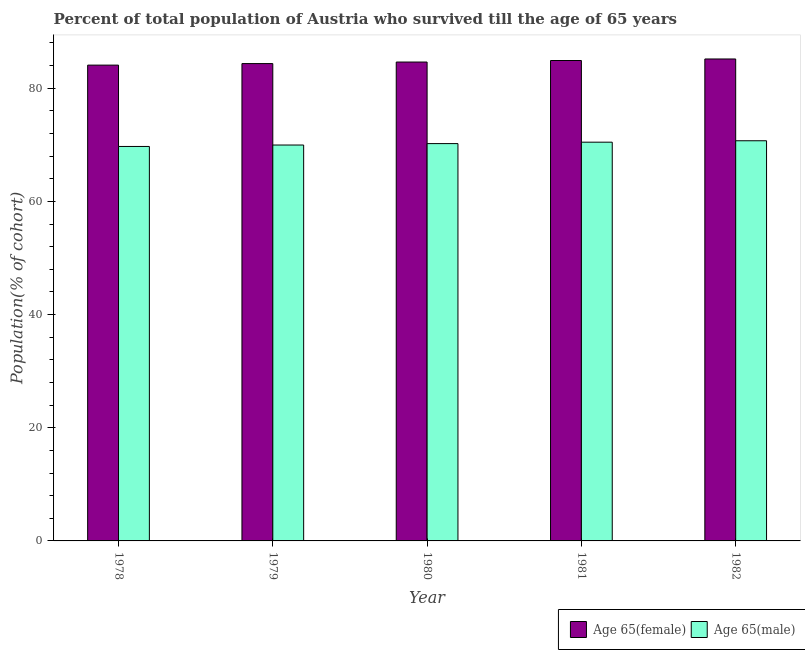How many different coloured bars are there?
Ensure brevity in your answer.  2. How many groups of bars are there?
Your answer should be very brief. 5. How many bars are there on the 5th tick from the left?
Make the answer very short. 2. How many bars are there on the 4th tick from the right?
Ensure brevity in your answer.  2. What is the label of the 1st group of bars from the left?
Make the answer very short. 1978. In how many cases, is the number of bars for a given year not equal to the number of legend labels?
Provide a short and direct response. 0. What is the percentage of female population who survived till age of 65 in 1978?
Your answer should be very brief. 84.09. Across all years, what is the maximum percentage of female population who survived till age of 65?
Your answer should be compact. 85.17. Across all years, what is the minimum percentage of female population who survived till age of 65?
Provide a succinct answer. 84.09. In which year was the percentage of male population who survived till age of 65 maximum?
Offer a terse response. 1982. In which year was the percentage of male population who survived till age of 65 minimum?
Provide a short and direct response. 1978. What is the total percentage of female population who survived till age of 65 in the graph?
Ensure brevity in your answer.  423.16. What is the difference between the percentage of male population who survived till age of 65 in 1979 and that in 1980?
Your response must be concise. -0.25. What is the difference between the percentage of female population who survived till age of 65 in 1979 and the percentage of male population who survived till age of 65 in 1980?
Your answer should be compact. -0.27. What is the average percentage of male population who survived till age of 65 per year?
Ensure brevity in your answer.  70.22. In the year 1979, what is the difference between the percentage of male population who survived till age of 65 and percentage of female population who survived till age of 65?
Provide a succinct answer. 0. In how many years, is the percentage of female population who survived till age of 65 greater than 24 %?
Offer a terse response. 5. What is the ratio of the percentage of male population who survived till age of 65 in 1981 to that in 1982?
Provide a succinct answer. 1. Is the percentage of female population who survived till age of 65 in 1981 less than that in 1982?
Offer a terse response. Yes. Is the difference between the percentage of male population who survived till age of 65 in 1978 and 1979 greater than the difference between the percentage of female population who survived till age of 65 in 1978 and 1979?
Your answer should be very brief. No. What is the difference between the highest and the second highest percentage of female population who survived till age of 65?
Your answer should be compact. 0.27. What is the difference between the highest and the lowest percentage of female population who survived till age of 65?
Provide a succinct answer. 1.09. Is the sum of the percentage of male population who survived till age of 65 in 1978 and 1980 greater than the maximum percentage of female population who survived till age of 65 across all years?
Provide a short and direct response. Yes. What does the 1st bar from the left in 1978 represents?
Your answer should be very brief. Age 65(female). What does the 2nd bar from the right in 1982 represents?
Ensure brevity in your answer.  Age 65(female). Are all the bars in the graph horizontal?
Make the answer very short. No. Are the values on the major ticks of Y-axis written in scientific E-notation?
Your answer should be compact. No. Where does the legend appear in the graph?
Give a very brief answer. Bottom right. How many legend labels are there?
Keep it short and to the point. 2. What is the title of the graph?
Provide a succinct answer. Percent of total population of Austria who survived till the age of 65 years. What is the label or title of the X-axis?
Offer a terse response. Year. What is the label or title of the Y-axis?
Make the answer very short. Population(% of cohort). What is the Population(% of cohort) of Age 65(female) in 1978?
Your response must be concise. 84.09. What is the Population(% of cohort) of Age 65(male) in 1978?
Offer a very short reply. 69.71. What is the Population(% of cohort) of Age 65(female) in 1979?
Provide a succinct answer. 84.36. What is the Population(% of cohort) in Age 65(male) in 1979?
Your response must be concise. 69.97. What is the Population(% of cohort) of Age 65(female) in 1980?
Your answer should be very brief. 84.63. What is the Population(% of cohort) of Age 65(male) in 1980?
Make the answer very short. 70.22. What is the Population(% of cohort) in Age 65(female) in 1981?
Ensure brevity in your answer.  84.9. What is the Population(% of cohort) in Age 65(male) in 1981?
Your answer should be compact. 70.47. What is the Population(% of cohort) of Age 65(female) in 1982?
Offer a terse response. 85.17. What is the Population(% of cohort) in Age 65(male) in 1982?
Your response must be concise. 70.72. Across all years, what is the maximum Population(% of cohort) of Age 65(female)?
Offer a very short reply. 85.17. Across all years, what is the maximum Population(% of cohort) in Age 65(male)?
Offer a very short reply. 70.72. Across all years, what is the minimum Population(% of cohort) in Age 65(female)?
Keep it short and to the point. 84.09. Across all years, what is the minimum Population(% of cohort) in Age 65(male)?
Offer a terse response. 69.71. What is the total Population(% of cohort) of Age 65(female) in the graph?
Your response must be concise. 423.16. What is the total Population(% of cohort) of Age 65(male) in the graph?
Your response must be concise. 351.09. What is the difference between the Population(% of cohort) in Age 65(female) in 1978 and that in 1979?
Your answer should be compact. -0.27. What is the difference between the Population(% of cohort) of Age 65(male) in 1978 and that in 1979?
Ensure brevity in your answer.  -0.25. What is the difference between the Population(% of cohort) of Age 65(female) in 1978 and that in 1980?
Your answer should be very brief. -0.54. What is the difference between the Population(% of cohort) of Age 65(male) in 1978 and that in 1980?
Provide a succinct answer. -0.5. What is the difference between the Population(% of cohort) of Age 65(female) in 1978 and that in 1981?
Provide a succinct answer. -0.81. What is the difference between the Population(% of cohort) in Age 65(male) in 1978 and that in 1981?
Offer a very short reply. -0.76. What is the difference between the Population(% of cohort) of Age 65(female) in 1978 and that in 1982?
Keep it short and to the point. -1.09. What is the difference between the Population(% of cohort) of Age 65(male) in 1978 and that in 1982?
Provide a succinct answer. -1.01. What is the difference between the Population(% of cohort) in Age 65(female) in 1979 and that in 1980?
Your answer should be very brief. -0.27. What is the difference between the Population(% of cohort) of Age 65(male) in 1979 and that in 1980?
Your answer should be compact. -0.25. What is the difference between the Population(% of cohort) of Age 65(female) in 1979 and that in 1981?
Your response must be concise. -0.54. What is the difference between the Population(% of cohort) of Age 65(male) in 1979 and that in 1981?
Give a very brief answer. -0.5. What is the difference between the Population(% of cohort) in Age 65(female) in 1979 and that in 1982?
Give a very brief answer. -0.81. What is the difference between the Population(% of cohort) of Age 65(male) in 1979 and that in 1982?
Ensure brevity in your answer.  -0.76. What is the difference between the Population(% of cohort) of Age 65(female) in 1980 and that in 1981?
Your response must be concise. -0.27. What is the difference between the Population(% of cohort) of Age 65(male) in 1980 and that in 1981?
Keep it short and to the point. -0.25. What is the difference between the Population(% of cohort) in Age 65(female) in 1980 and that in 1982?
Make the answer very short. -0.54. What is the difference between the Population(% of cohort) in Age 65(male) in 1980 and that in 1982?
Provide a succinct answer. -0.5. What is the difference between the Population(% of cohort) of Age 65(female) in 1981 and that in 1982?
Keep it short and to the point. -0.27. What is the difference between the Population(% of cohort) of Age 65(male) in 1981 and that in 1982?
Give a very brief answer. -0.25. What is the difference between the Population(% of cohort) of Age 65(female) in 1978 and the Population(% of cohort) of Age 65(male) in 1979?
Provide a short and direct response. 14.12. What is the difference between the Population(% of cohort) in Age 65(female) in 1978 and the Population(% of cohort) in Age 65(male) in 1980?
Your answer should be compact. 13.87. What is the difference between the Population(% of cohort) of Age 65(female) in 1978 and the Population(% of cohort) of Age 65(male) in 1981?
Provide a short and direct response. 13.62. What is the difference between the Population(% of cohort) of Age 65(female) in 1978 and the Population(% of cohort) of Age 65(male) in 1982?
Provide a succinct answer. 13.37. What is the difference between the Population(% of cohort) in Age 65(female) in 1979 and the Population(% of cohort) in Age 65(male) in 1980?
Your answer should be compact. 14.14. What is the difference between the Population(% of cohort) in Age 65(female) in 1979 and the Population(% of cohort) in Age 65(male) in 1981?
Your answer should be compact. 13.89. What is the difference between the Population(% of cohort) in Age 65(female) in 1979 and the Population(% of cohort) in Age 65(male) in 1982?
Keep it short and to the point. 13.64. What is the difference between the Population(% of cohort) in Age 65(female) in 1980 and the Population(% of cohort) in Age 65(male) in 1981?
Keep it short and to the point. 14.16. What is the difference between the Population(% of cohort) of Age 65(female) in 1980 and the Population(% of cohort) of Age 65(male) in 1982?
Offer a terse response. 13.91. What is the difference between the Population(% of cohort) in Age 65(female) in 1981 and the Population(% of cohort) in Age 65(male) in 1982?
Provide a succinct answer. 14.18. What is the average Population(% of cohort) of Age 65(female) per year?
Provide a succinct answer. 84.63. What is the average Population(% of cohort) in Age 65(male) per year?
Provide a succinct answer. 70.22. In the year 1978, what is the difference between the Population(% of cohort) in Age 65(female) and Population(% of cohort) in Age 65(male)?
Provide a short and direct response. 14.37. In the year 1979, what is the difference between the Population(% of cohort) of Age 65(female) and Population(% of cohort) of Age 65(male)?
Make the answer very short. 14.39. In the year 1980, what is the difference between the Population(% of cohort) in Age 65(female) and Population(% of cohort) in Age 65(male)?
Your answer should be very brief. 14.41. In the year 1981, what is the difference between the Population(% of cohort) in Age 65(female) and Population(% of cohort) in Age 65(male)?
Ensure brevity in your answer.  14.43. In the year 1982, what is the difference between the Population(% of cohort) in Age 65(female) and Population(% of cohort) in Age 65(male)?
Provide a succinct answer. 14.45. What is the ratio of the Population(% of cohort) of Age 65(male) in 1978 to that in 1980?
Ensure brevity in your answer.  0.99. What is the ratio of the Population(% of cohort) of Age 65(female) in 1978 to that in 1981?
Provide a succinct answer. 0.99. What is the ratio of the Population(% of cohort) in Age 65(male) in 1978 to that in 1981?
Make the answer very short. 0.99. What is the ratio of the Population(% of cohort) in Age 65(female) in 1978 to that in 1982?
Ensure brevity in your answer.  0.99. What is the ratio of the Population(% of cohort) in Age 65(male) in 1978 to that in 1982?
Your response must be concise. 0.99. What is the ratio of the Population(% of cohort) of Age 65(female) in 1979 to that in 1980?
Offer a very short reply. 1. What is the ratio of the Population(% of cohort) in Age 65(male) in 1979 to that in 1980?
Keep it short and to the point. 1. What is the ratio of the Population(% of cohort) of Age 65(female) in 1979 to that in 1982?
Your response must be concise. 0.99. What is the ratio of the Population(% of cohort) in Age 65(male) in 1979 to that in 1982?
Ensure brevity in your answer.  0.99. What is the ratio of the Population(% of cohort) of Age 65(male) in 1980 to that in 1981?
Keep it short and to the point. 1. What is the ratio of the Population(% of cohort) of Age 65(female) in 1980 to that in 1982?
Ensure brevity in your answer.  0.99. What is the ratio of the Population(% of cohort) in Age 65(male) in 1980 to that in 1982?
Provide a succinct answer. 0.99. What is the ratio of the Population(% of cohort) in Age 65(female) in 1981 to that in 1982?
Make the answer very short. 1. What is the ratio of the Population(% of cohort) of Age 65(male) in 1981 to that in 1982?
Provide a succinct answer. 1. What is the difference between the highest and the second highest Population(% of cohort) in Age 65(female)?
Your answer should be very brief. 0.27. What is the difference between the highest and the second highest Population(% of cohort) in Age 65(male)?
Offer a very short reply. 0.25. What is the difference between the highest and the lowest Population(% of cohort) in Age 65(female)?
Your response must be concise. 1.09. What is the difference between the highest and the lowest Population(% of cohort) of Age 65(male)?
Your answer should be compact. 1.01. 